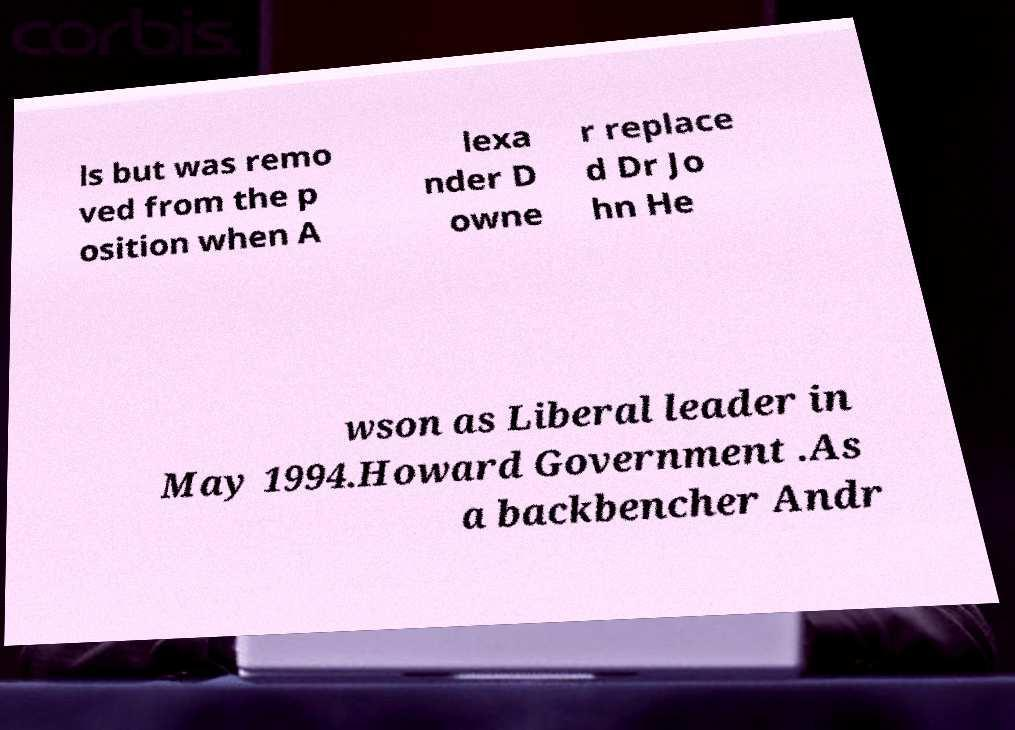What messages or text are displayed in this image? I need them in a readable, typed format. ls but was remo ved from the p osition when A lexa nder D owne r replace d Dr Jo hn He wson as Liberal leader in May 1994.Howard Government .As a backbencher Andr 